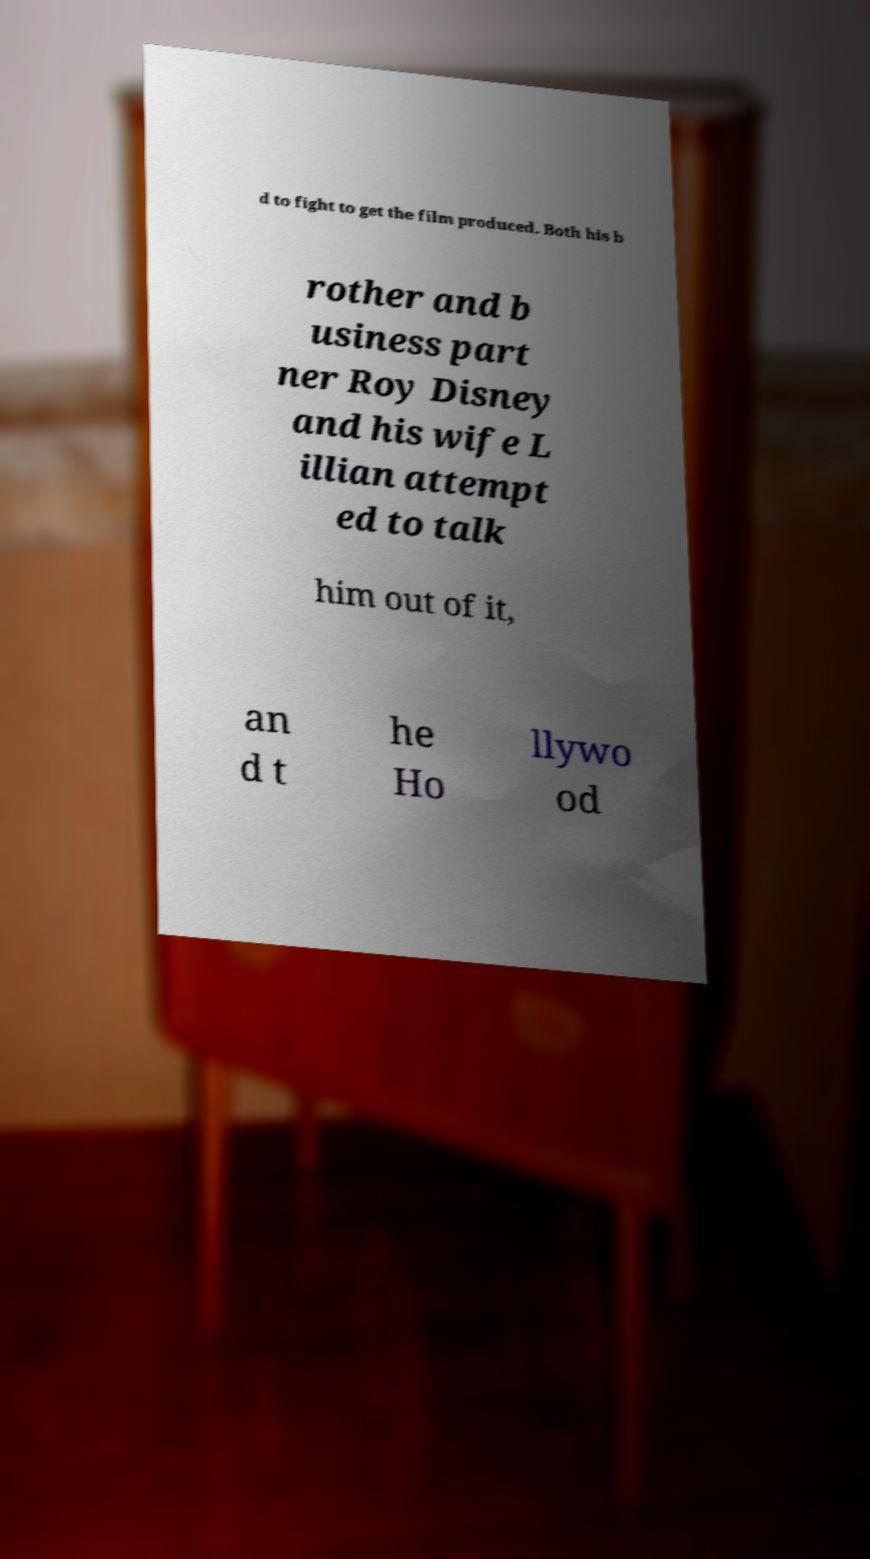What messages or text are displayed in this image? I need them in a readable, typed format. d to fight to get the film produced. Both his b rother and b usiness part ner Roy Disney and his wife L illian attempt ed to talk him out of it, an d t he Ho llywo od 